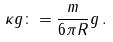Convert formula to latex. <formula><loc_0><loc_0><loc_500><loc_500>\kappa g \colon = \frac { m } { 6 \pi R } g \, .</formula> 